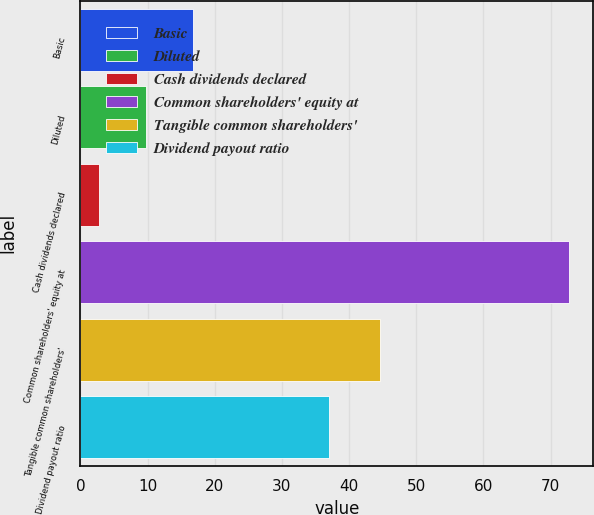<chart> <loc_0><loc_0><loc_500><loc_500><bar_chart><fcel>Basic<fcel>Diluted<fcel>Cash dividends declared<fcel>Common shareholders' equity at<fcel>Tangible common shareholders'<fcel>Dividend payout ratio<nl><fcel>16.78<fcel>9.79<fcel>2.8<fcel>72.73<fcel>44.61<fcel>36.98<nl></chart> 